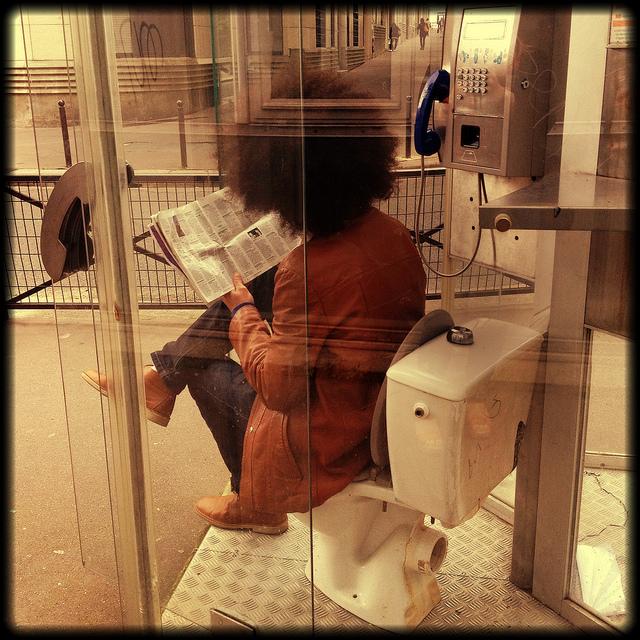What color is the toilet?
Quick response, please. White. What is the lady inside of?
Concise answer only. Phone booth. What type of hairstyle does the woman have?
Keep it brief. Afro. 